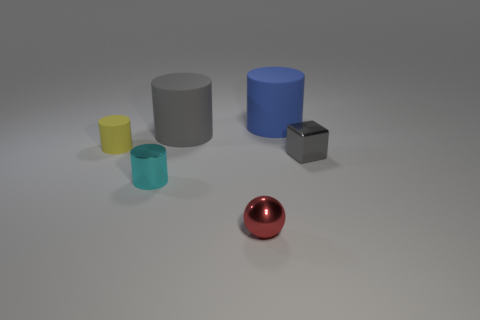Add 2 tiny spheres. How many objects exist? 8 Subtract all cylinders. How many objects are left? 2 Subtract all blue objects. Subtract all small cyan things. How many objects are left? 4 Add 3 large blue things. How many large blue things are left? 4 Add 1 yellow matte blocks. How many yellow matte blocks exist? 1 Subtract 1 yellow cylinders. How many objects are left? 5 